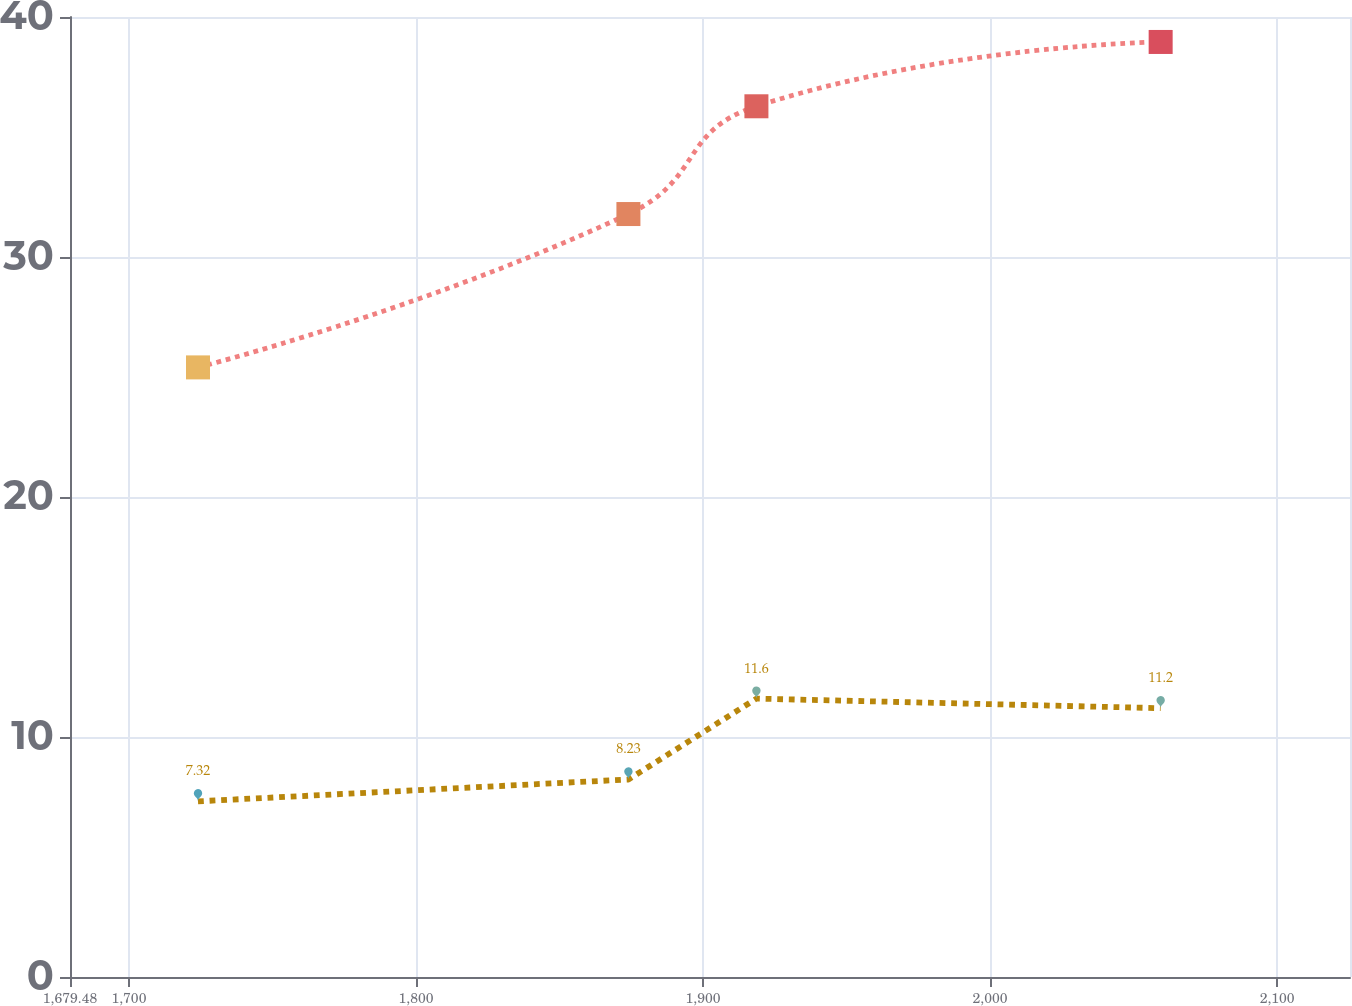Convert chart to OTSL. <chart><loc_0><loc_0><loc_500><loc_500><line_chart><ecel><fcel>International<fcel>United States<nl><fcel>1724.07<fcel>25.4<fcel>7.32<nl><fcel>1874.01<fcel>31.79<fcel>8.23<nl><fcel>1918.6<fcel>36.28<fcel>11.6<nl><fcel>2059.42<fcel>38.96<fcel>11.2<nl><fcel>2169.97<fcel>30.43<fcel>10<nl></chart> 